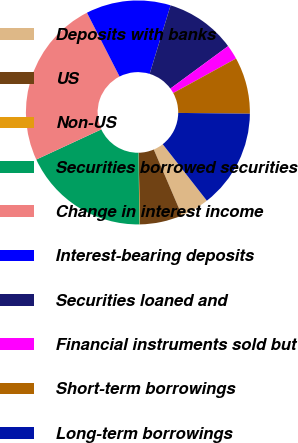Convert chart to OTSL. <chart><loc_0><loc_0><loc_500><loc_500><pie_chart><fcel>Deposits with banks<fcel>US<fcel>Non-US<fcel>Securities borrowed securities<fcel>Change in interest income<fcel>Interest-bearing deposits<fcel>Securities loaned and<fcel>Financial instruments sold but<fcel>Short-term borrowings<fcel>Long-term borrowings<nl><fcel>4.12%<fcel>6.15%<fcel>0.07%<fcel>18.31%<fcel>24.39%<fcel>12.23%<fcel>10.2%<fcel>2.09%<fcel>8.18%<fcel>14.26%<nl></chart> 